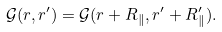Convert formula to latex. <formula><loc_0><loc_0><loc_500><loc_500>\mathcal { G } ( r , r ^ { \prime } ) = \mathcal { G } ( r + R _ { \| } , r ^ { \prime } + R ^ { \prime } _ { \| } ) .</formula> 